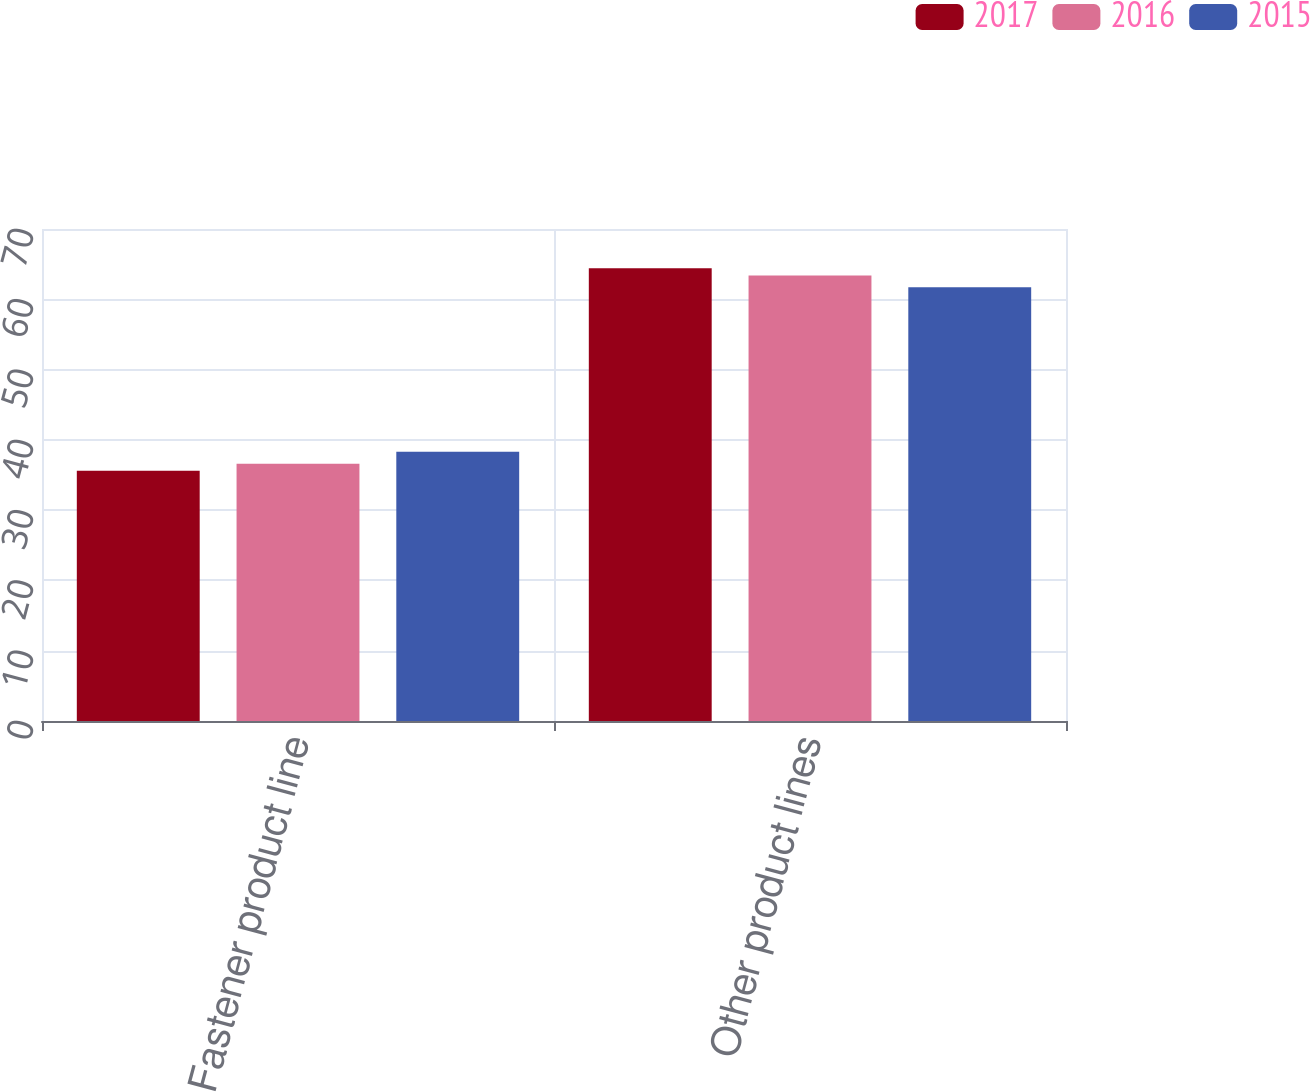<chart> <loc_0><loc_0><loc_500><loc_500><stacked_bar_chart><ecel><fcel>Fastener product line<fcel>Other product lines<nl><fcel>2017<fcel>35.6<fcel>64.4<nl><fcel>2016<fcel>36.6<fcel>63.4<nl><fcel>2015<fcel>38.3<fcel>61.7<nl></chart> 